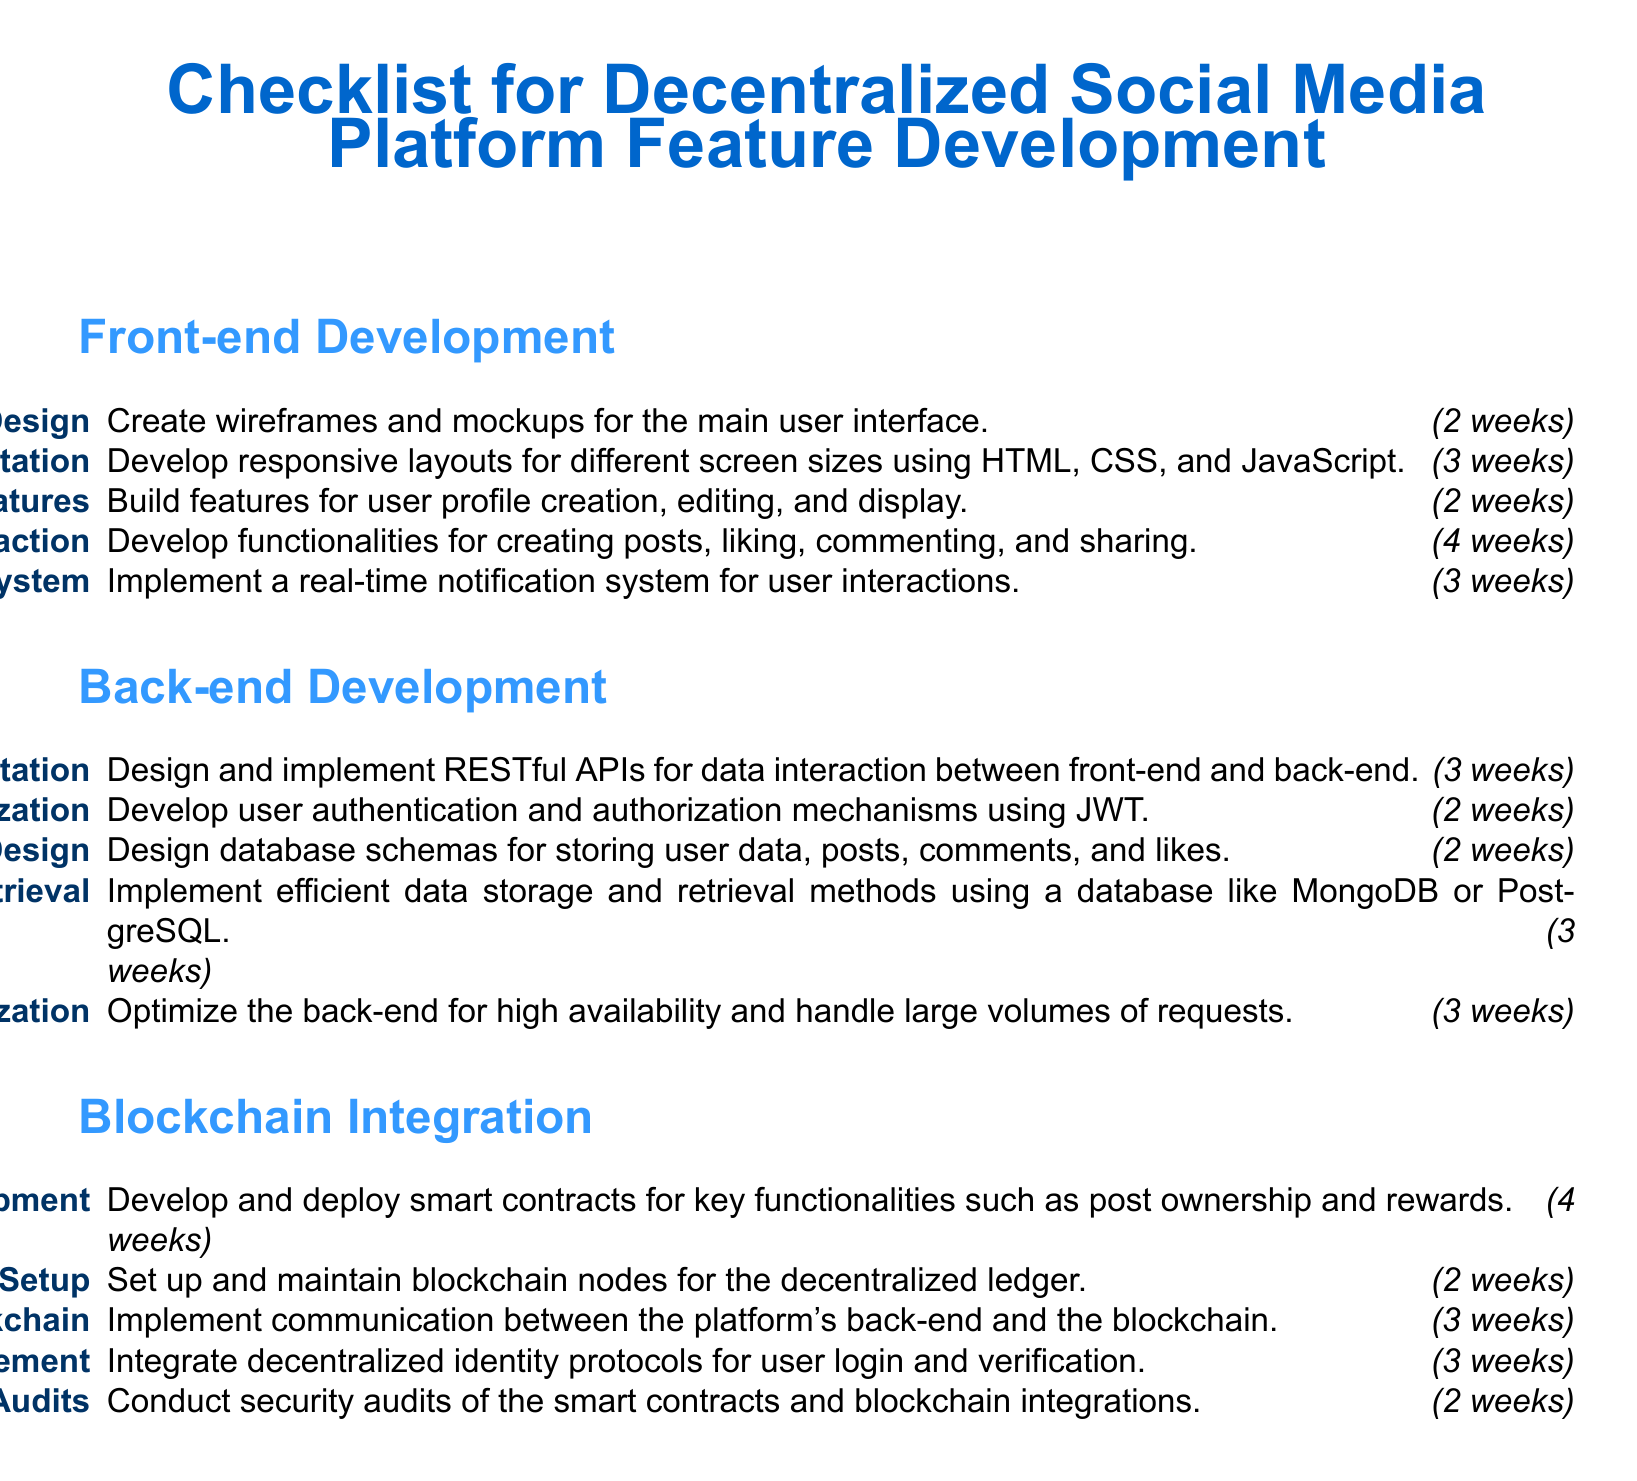What is the timeline for User Interface Design? The timeline for User Interface Design is stated in the document as 2 weeks.
Answer: 2 weeks How long is allocated for Smart Contract Development? The document specifies that Smart Contract Development will take 4 weeks.
Answer: 4 weeks What feature involves Creating and Editing Profiles? The feature involving creating and editing profiles is titled "User Profile Features" as described in the front-end section.
Answer: User Profile Features How many tasks are listed under Back-end Development? The document lists a total of five tasks in the Back-end Development section.
Answer: 5 tasks What is the total timeline allocated for implementing the Notification System? The document mentions that the Notification System will take 3 weeks to implement.
Answer: 3 weeks Which technology is mentioned for user authentication? The technology mentioned for user authentication is JWT.
Answer: JWT What is the purpose of Decentralized Identity Management? The purpose of Decentralized Identity Management is to integrate decentralized identity protocols for user login and verification.
Answer: User login and verification Which task should be completed first in the Back-end section? The first task to be completed in the Back-end section is API Design and Implementation.
Answer: API Design and Implementation What is the timeline for Security Audits? The timeline for conducting Security Audits is stated as 2 weeks.
Answer: 2 weeks 